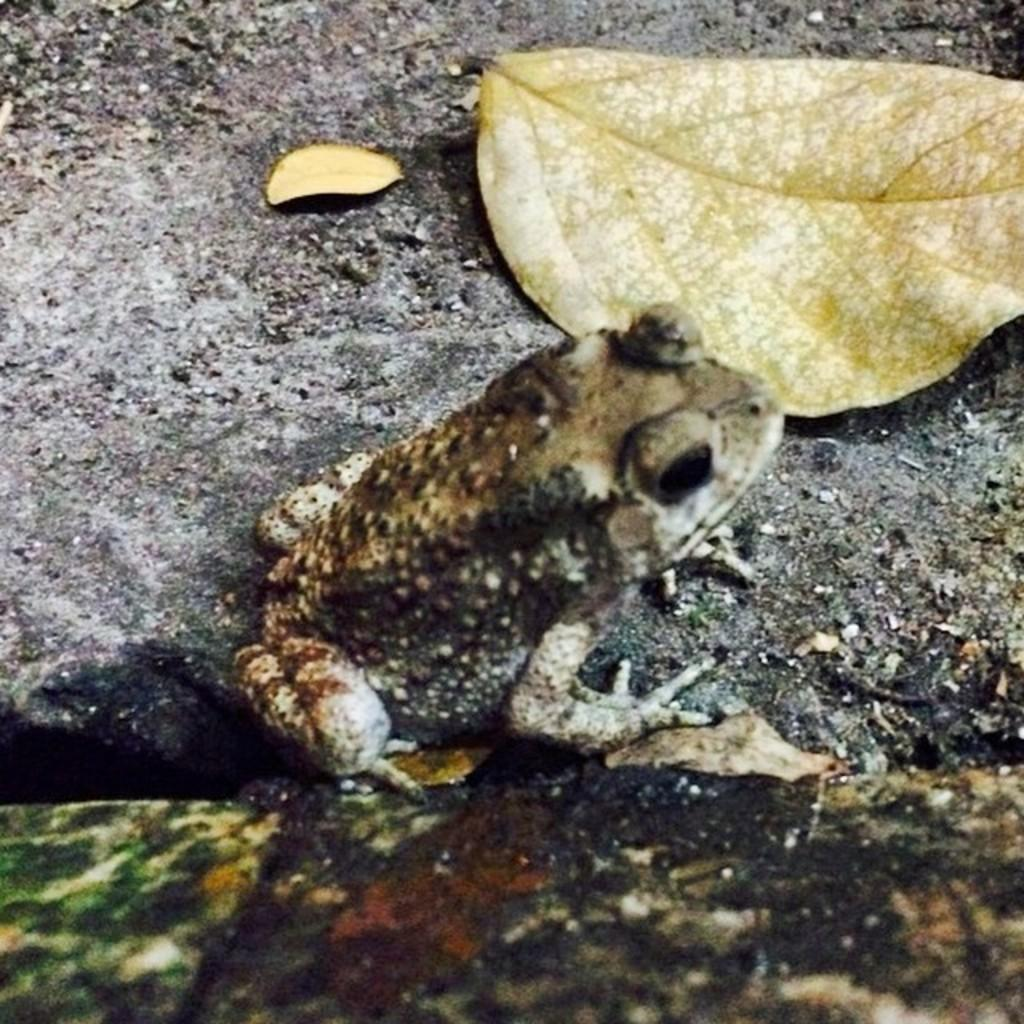What animal is present in the picture? There is a frog in the picture. What object is located beside the frog? There is a dried leaf beside the frog. What type of dock can be seen in the picture? There is no dock present in the picture; it features a frog and a dried leaf. What system is responsible for the fog in the picture? There is no fog present in the picture, and therefore no system is responsible for it. 